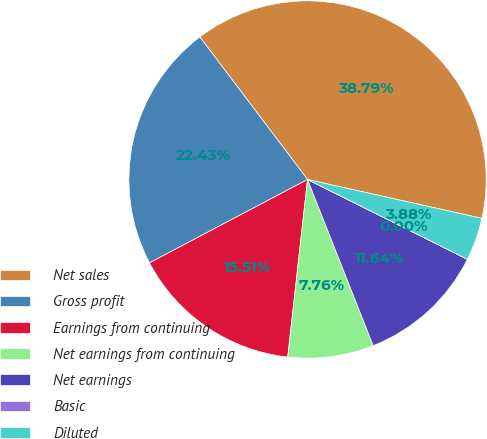<chart> <loc_0><loc_0><loc_500><loc_500><pie_chart><fcel>Net sales<fcel>Gross profit<fcel>Earnings from continuing<fcel>Net earnings from continuing<fcel>Net earnings<fcel>Basic<fcel>Diluted<nl><fcel>38.79%<fcel>22.43%<fcel>15.51%<fcel>7.76%<fcel>11.64%<fcel>0.0%<fcel>3.88%<nl></chart> 